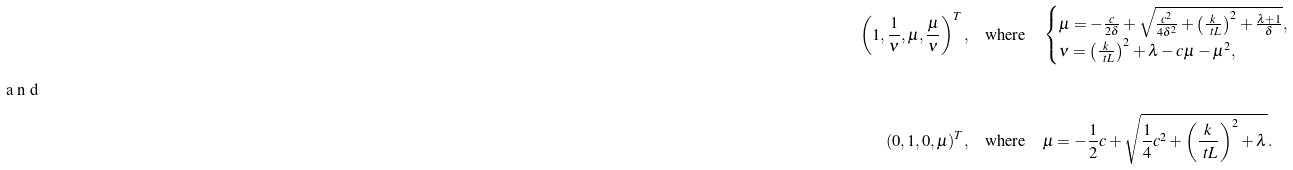Convert formula to latex. <formula><loc_0><loc_0><loc_500><loc_500>\left ( 1 , \frac { 1 } { \nu } , \mu , \frac { \mu } { \nu } \right ) ^ { T } , & \quad \text {where} \quad \begin{cases} \mu = - \frac { c } { 2 \delta } + \sqrt { \frac { c ^ { 2 } } { 4 \delta ^ { 2 } } + \left ( \frac { k } { \ t L } \right ) ^ { 2 } + \frac { \lambda + 1 } { \delta } } , \\ \nu = \left ( \frac { k } { \ t L } \right ) ^ { 2 } + \lambda - c \mu - \mu ^ { 2 } , \end{cases} \\ \intertext { a n d } ( 0 , 1 , 0 , \mu ) ^ { T } , & \quad \text {where} \quad \mu = - \frac { 1 } { 2 } c + \sqrt { \frac { 1 } { 4 } c ^ { 2 } + \left ( \frac { k } { \ t L } \right ) ^ { 2 } + \lambda } .</formula> 